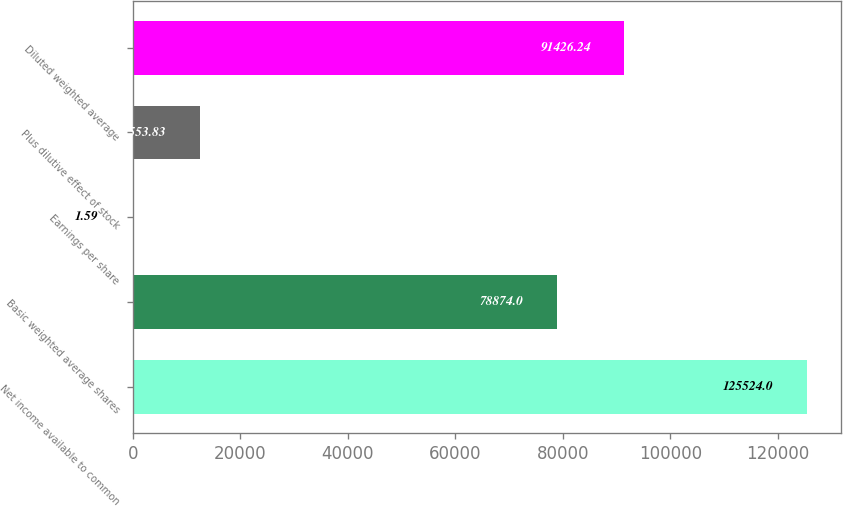Convert chart to OTSL. <chart><loc_0><loc_0><loc_500><loc_500><bar_chart><fcel>Net income available to common<fcel>Basic weighted average shares<fcel>Earnings per share<fcel>Plus dilutive effect of stock<fcel>Diluted weighted average<nl><fcel>125524<fcel>78874<fcel>1.59<fcel>12553.8<fcel>91426.2<nl></chart> 